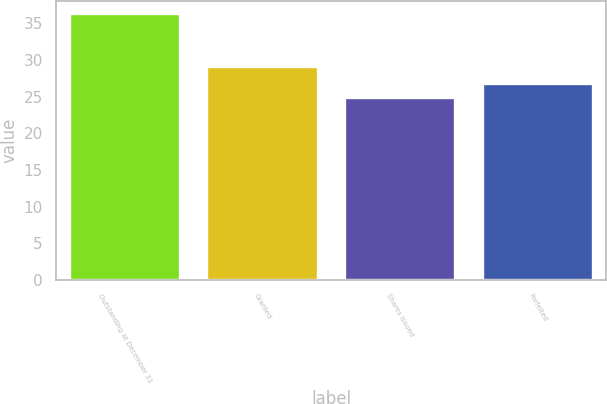Convert chart. <chart><loc_0><loc_0><loc_500><loc_500><bar_chart><fcel>Outstanding at December 31<fcel>Granted<fcel>Shares issued<fcel>Forfeited<nl><fcel>36.24<fcel>29.06<fcel>24.84<fcel>26.78<nl></chart> 